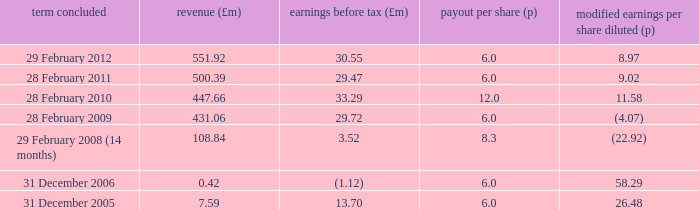How many items appear in the dividend per share when the turnover is 0.42? 1.0. 